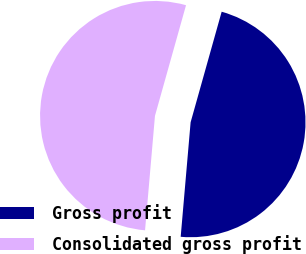Convert chart to OTSL. <chart><loc_0><loc_0><loc_500><loc_500><pie_chart><fcel>Gross profit<fcel>Consolidated gross profit<nl><fcel>47.02%<fcel>52.98%<nl></chart> 